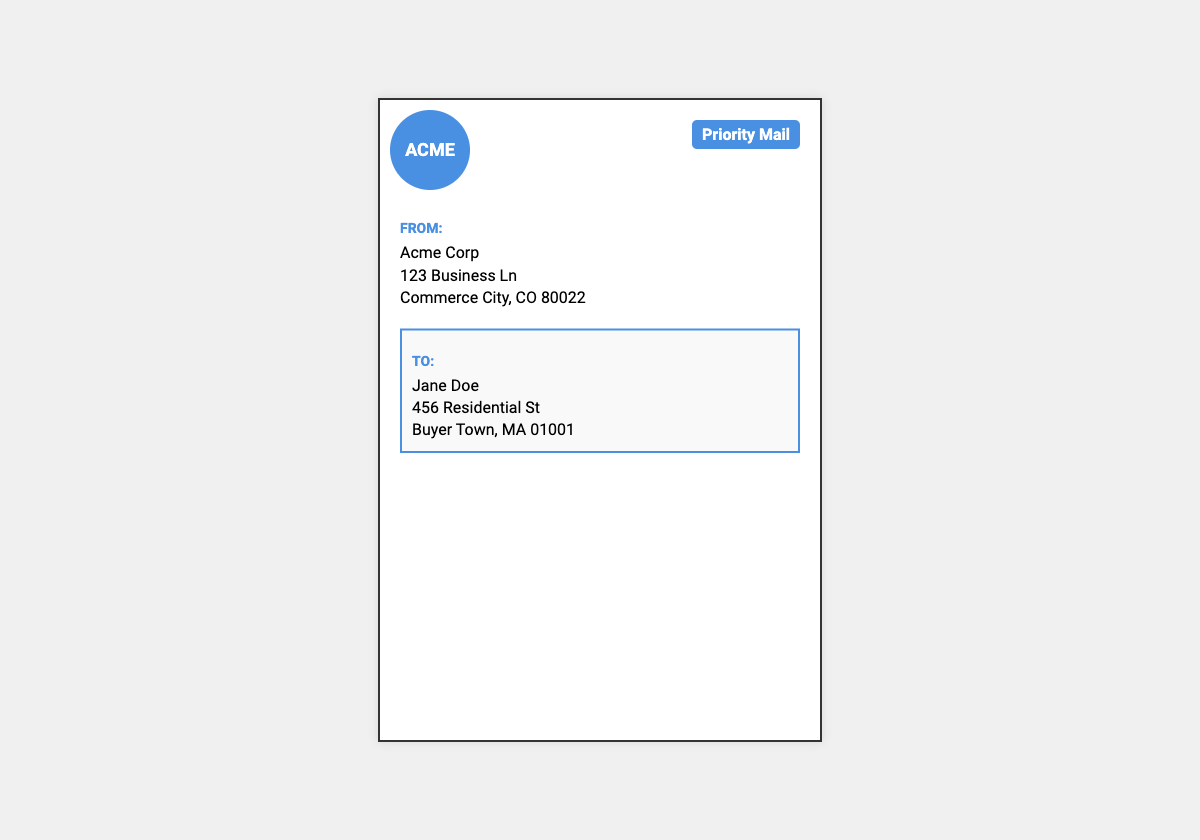What is the sender's company name? The sender's company name is found at the top of the sender section.
Answer: Acme Corp What is the recipient's name? The recipient's name is displayed in the recipient section.
Answer: Jane Doe What is the sender's address? The sender's address can be found listed below their name in the document.
Answer: 123 Business Ln, Commerce City, CO 80022 What shipping method is used? The shipping method is indicated in the shipping label prominently at the top right.
Answer: Priority Mail What is the barcode's position in the document? The barcode is placed at the bottom of the shipping label, center-aligned.
Answer: Bottom center How large is the shipping label? The shipping label dimensions are given in its width and height properties.
Answer: 400 x 600 pixels What color is the shipping method label? The color of the shipping method label can be identified visually in the document.
Answer: White How might the logo be described? The logo has specific features that make it stand out in the design.
Answer: Circular, blue background with white text What is the background color of the shipping label? The background color of the shipping label is specified in the design section.
Answer: White 